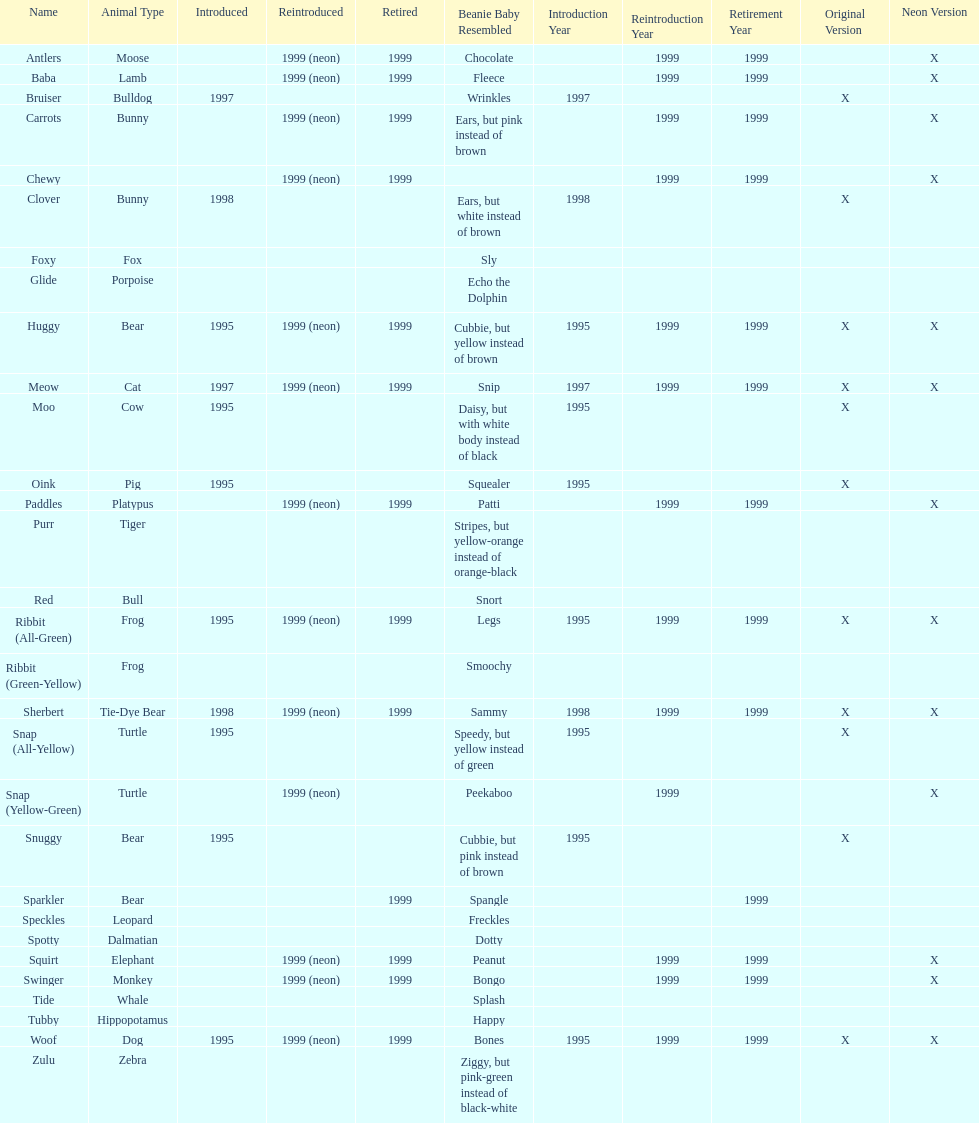What is the name of the last pillow pal on this chart? Zulu. 